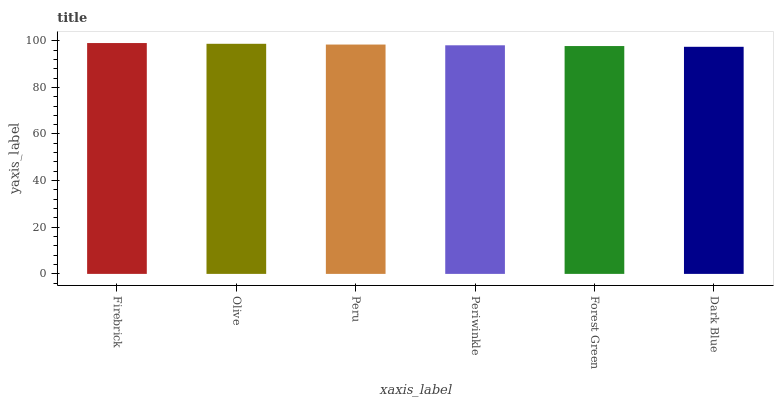Is Dark Blue the minimum?
Answer yes or no. Yes. Is Firebrick the maximum?
Answer yes or no. Yes. Is Olive the minimum?
Answer yes or no. No. Is Olive the maximum?
Answer yes or no. No. Is Firebrick greater than Olive?
Answer yes or no. Yes. Is Olive less than Firebrick?
Answer yes or no. Yes. Is Olive greater than Firebrick?
Answer yes or no. No. Is Firebrick less than Olive?
Answer yes or no. No. Is Peru the high median?
Answer yes or no. Yes. Is Periwinkle the low median?
Answer yes or no. Yes. Is Olive the high median?
Answer yes or no. No. Is Olive the low median?
Answer yes or no. No. 